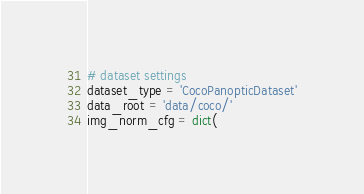Convert code to text. <code><loc_0><loc_0><loc_500><loc_500><_Python_># dataset settings
dataset_type = 'CocoPanopticDataset'
data_root = 'data/coco/'
img_norm_cfg = dict(</code> 